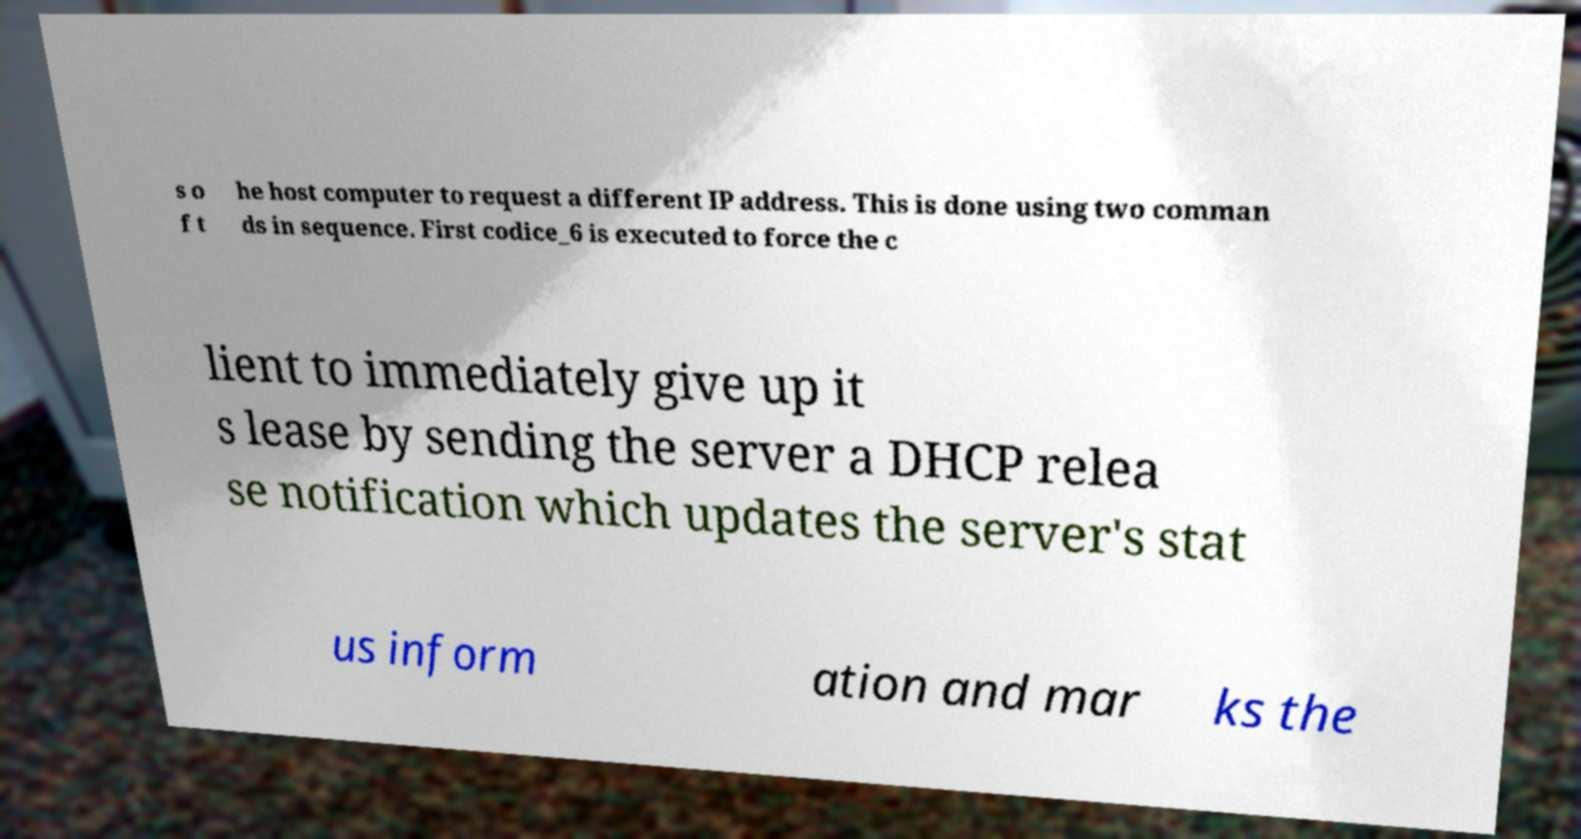Please read and relay the text visible in this image. What does it say? s o f t he host computer to request a different IP address. This is done using two comman ds in sequence. First codice_6 is executed to force the c lient to immediately give up it s lease by sending the server a DHCP relea se notification which updates the server's stat us inform ation and mar ks the 